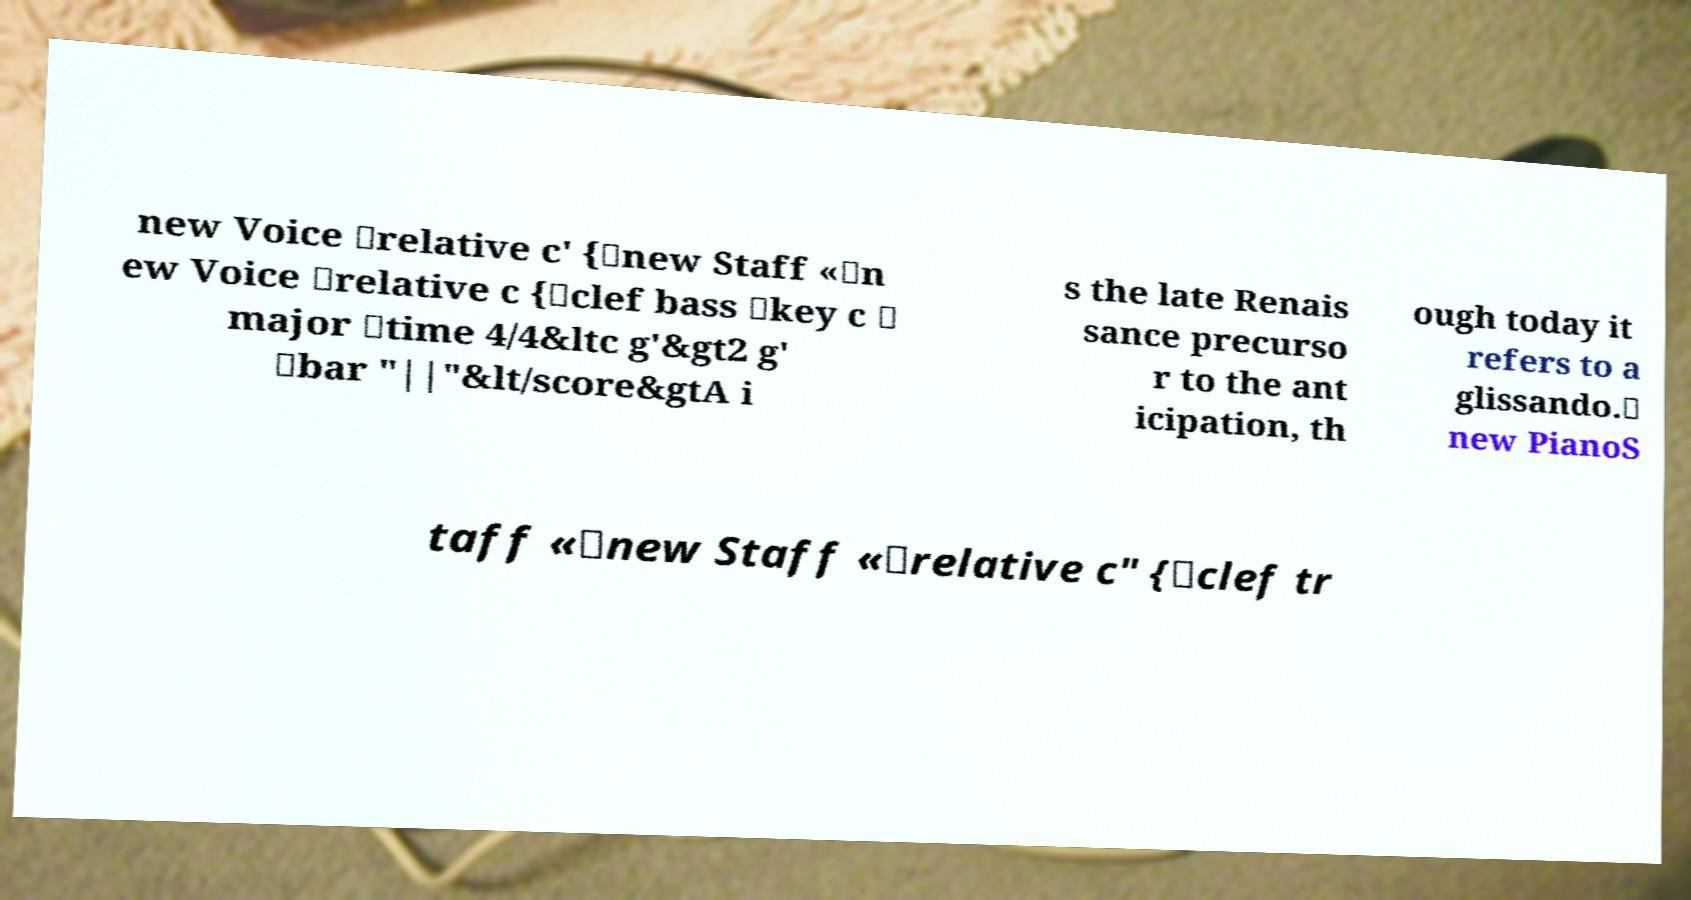For documentation purposes, I need the text within this image transcribed. Could you provide that? new Voice \relative c' {\new Staff «\n ew Voice \relative c {\clef bass \key c \ major \time 4/4&ltc g'&gt2 g' \bar "||"&lt/score&gtA i s the late Renais sance precurso r to the ant icipation, th ough today it refers to a glissando.\ new PianoS taff «\new Staff «\relative c" {\clef tr 